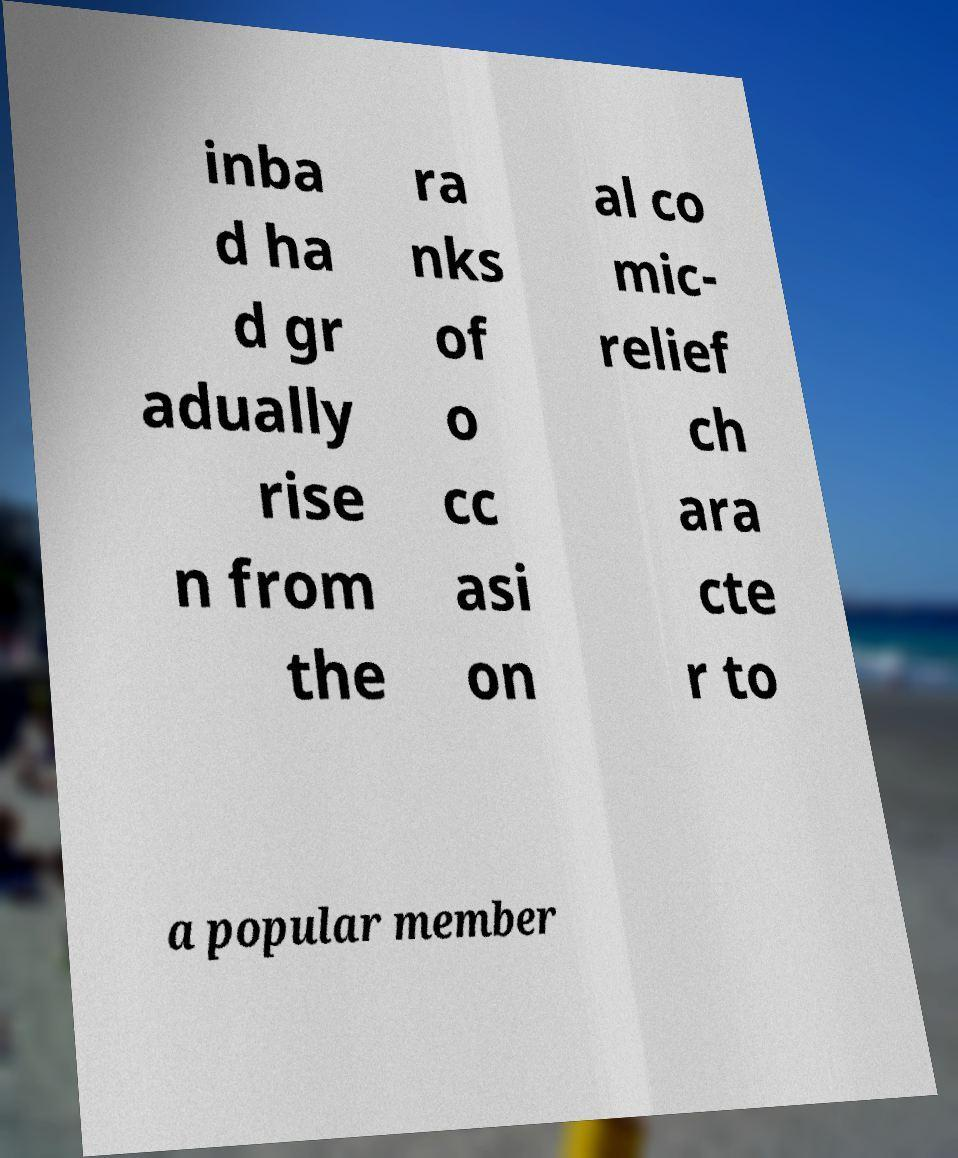Can you read and provide the text displayed in the image?This photo seems to have some interesting text. Can you extract and type it out for me? inba d ha d gr adually rise n from the ra nks of o cc asi on al co mic- relief ch ara cte r to a popular member 